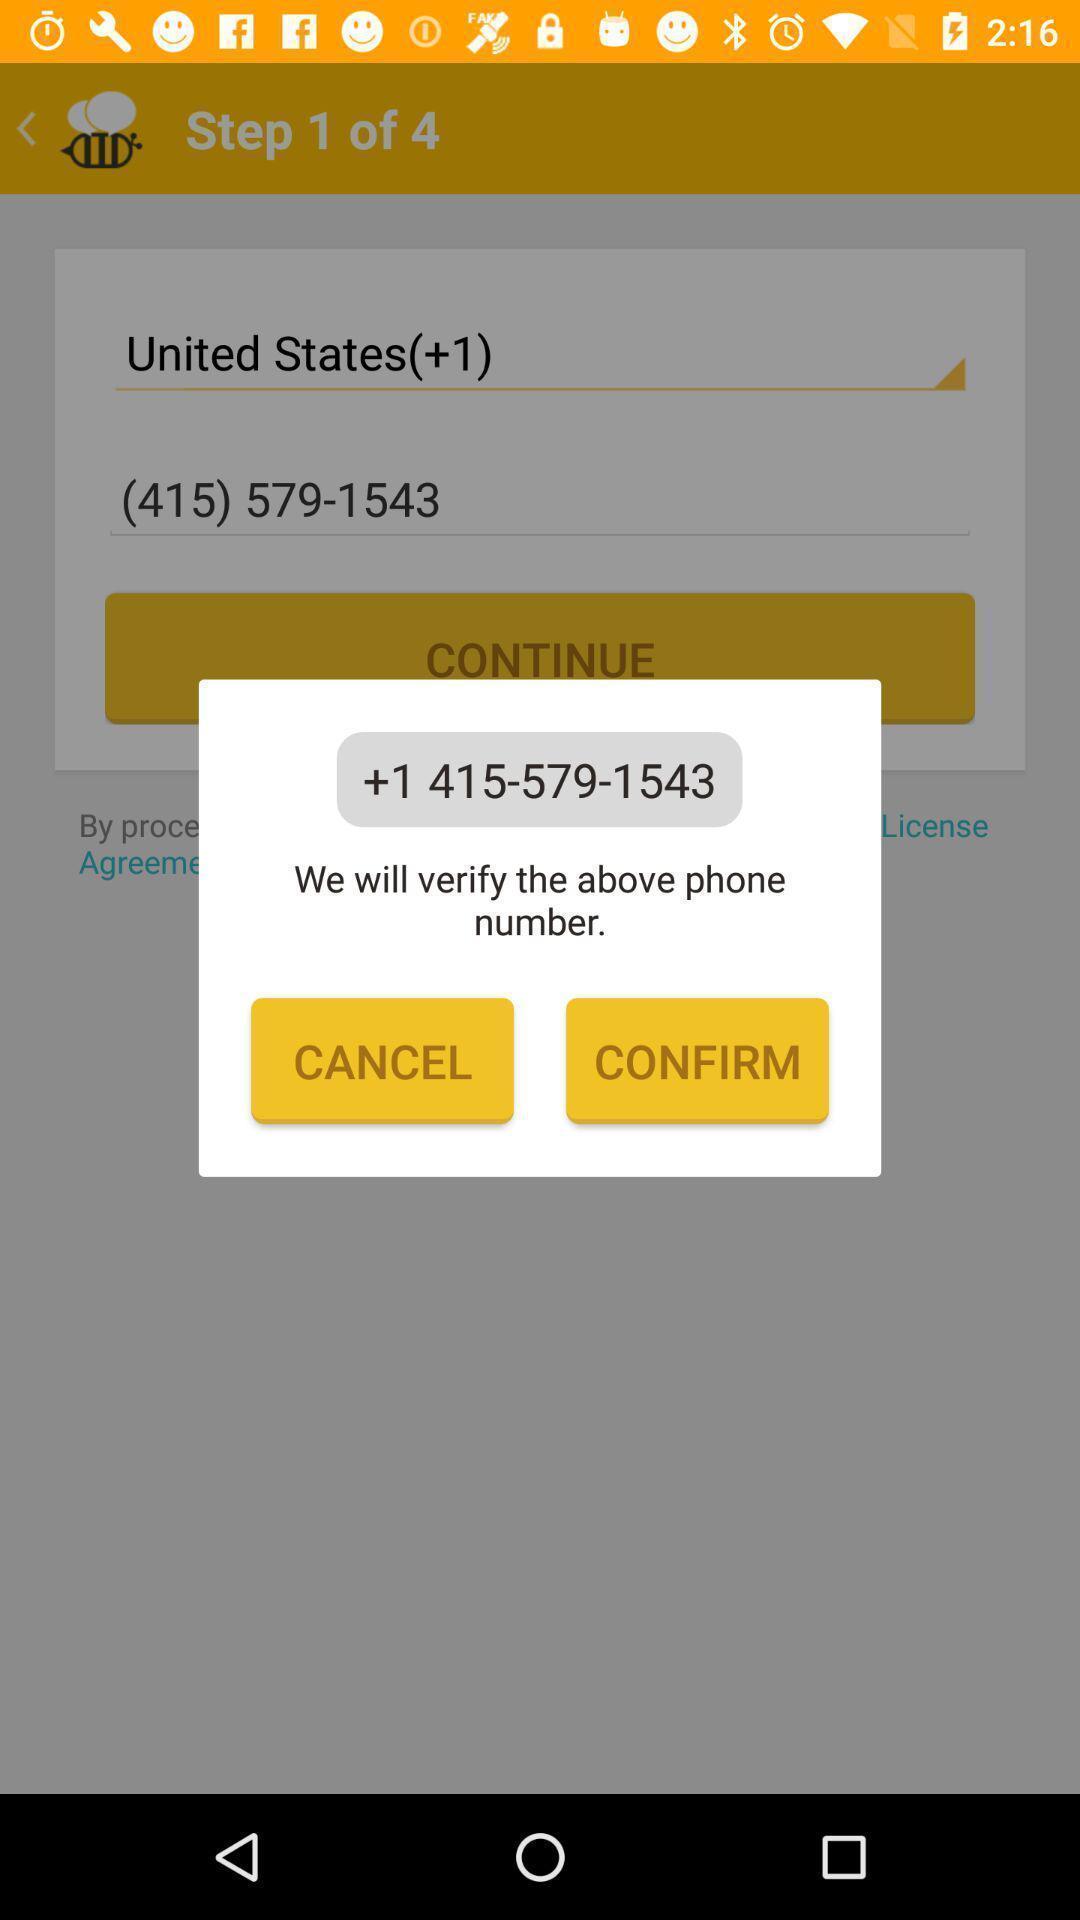Provide a textual representation of this image. Pop-up asking to verify the phone number. 